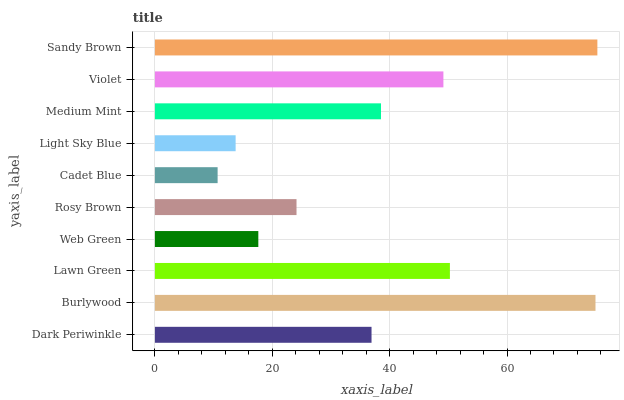Is Cadet Blue the minimum?
Answer yes or no. Yes. Is Sandy Brown the maximum?
Answer yes or no. Yes. Is Burlywood the minimum?
Answer yes or no. No. Is Burlywood the maximum?
Answer yes or no. No. Is Burlywood greater than Dark Periwinkle?
Answer yes or no. Yes. Is Dark Periwinkle less than Burlywood?
Answer yes or no. Yes. Is Dark Periwinkle greater than Burlywood?
Answer yes or no. No. Is Burlywood less than Dark Periwinkle?
Answer yes or no. No. Is Medium Mint the high median?
Answer yes or no. Yes. Is Dark Periwinkle the low median?
Answer yes or no. Yes. Is Cadet Blue the high median?
Answer yes or no. No. Is Rosy Brown the low median?
Answer yes or no. No. 